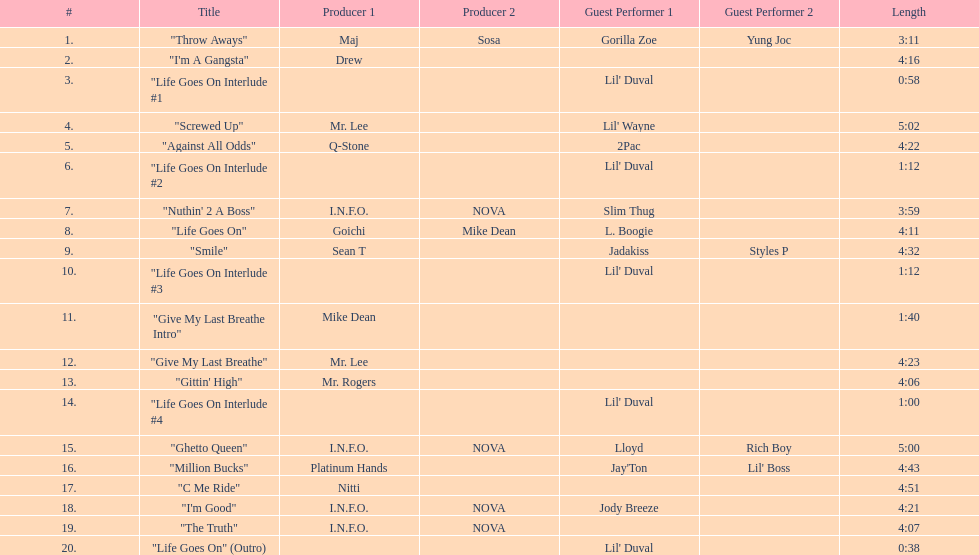How long is the longest track on the album? 5:02. 